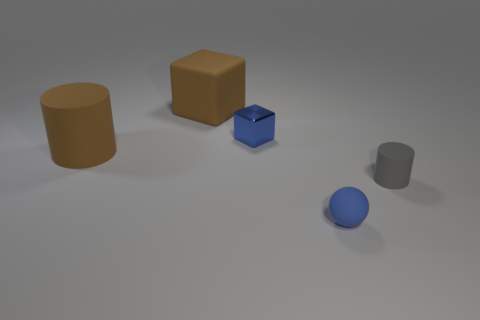Add 3 brown cylinders. How many objects exist? 8 Subtract all cylinders. How many objects are left? 3 Subtract all blue cubes. How many cubes are left? 1 Add 3 matte cubes. How many matte cubes are left? 4 Add 4 big brown matte cylinders. How many big brown matte cylinders exist? 5 Subtract 1 blue balls. How many objects are left? 4 Subtract 2 blocks. How many blocks are left? 0 Subtract all yellow cubes. Subtract all purple spheres. How many cubes are left? 2 Subtract all gray rubber objects. Subtract all brown rubber cylinders. How many objects are left? 3 